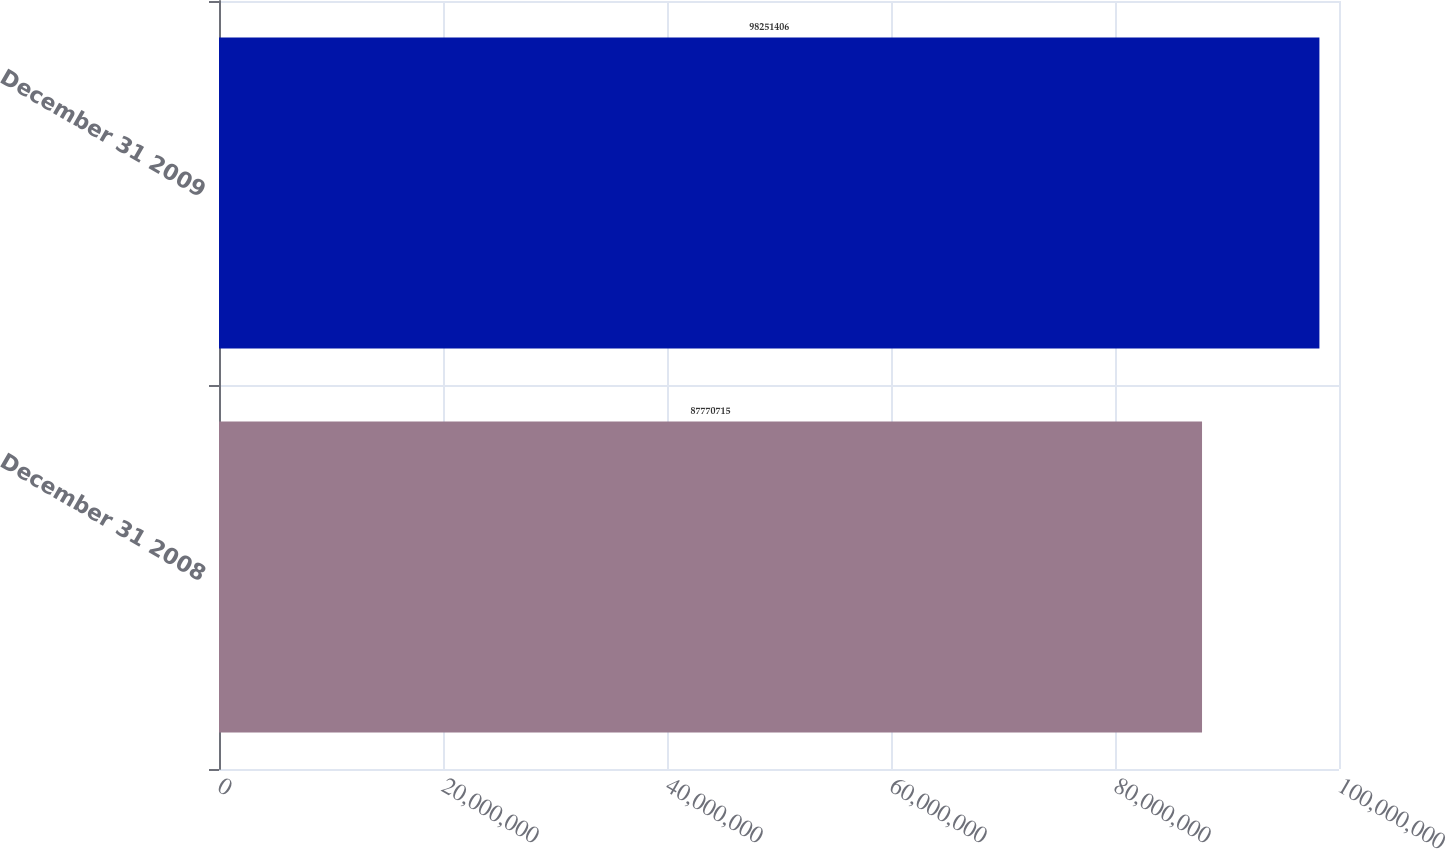Convert chart. <chart><loc_0><loc_0><loc_500><loc_500><bar_chart><fcel>December 31 2008<fcel>December 31 2009<nl><fcel>8.77707e+07<fcel>9.82514e+07<nl></chart> 